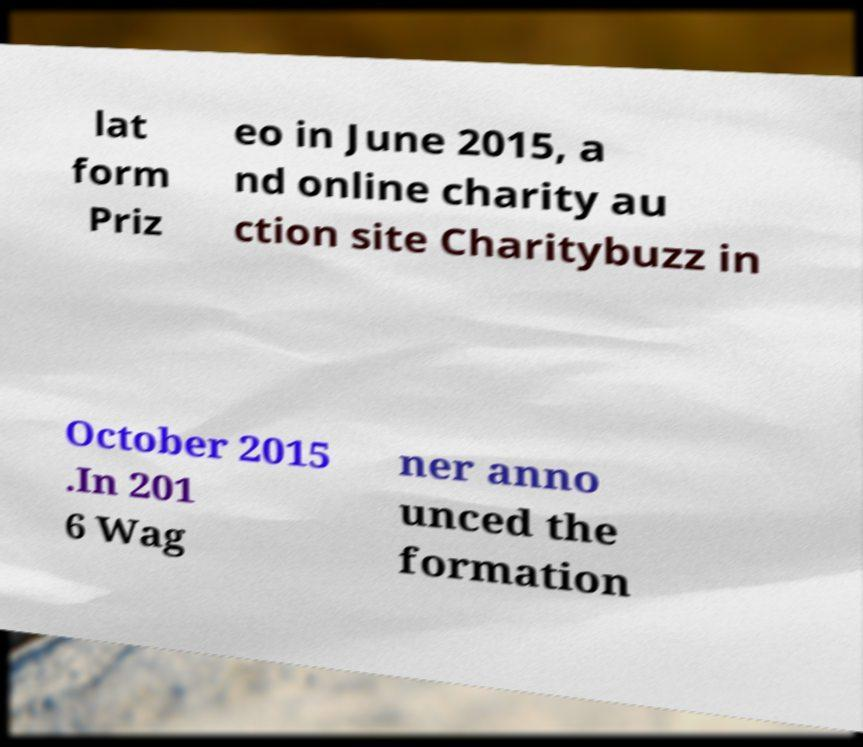Could you extract and type out the text from this image? lat form Priz eo in June 2015, a nd online charity au ction site Charitybuzz in October 2015 .In 201 6 Wag ner anno unced the formation 